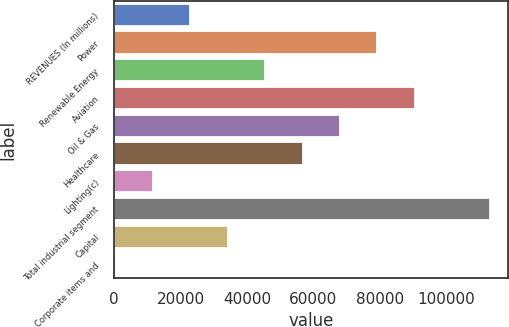Convert chart to OTSL. <chart><loc_0><loc_0><loc_500><loc_500><bar_chart><fcel>REVENUES (In millions)<fcel>Power<fcel>Renewable Energy<fcel>Aviation<fcel>Oil & Gas<fcel>Healthcare<fcel>Lighting(c)<fcel>Total industrial segment<fcel>Capital<fcel>Corporate items and<nl><fcel>22967.6<fcel>79229.1<fcel>45472.2<fcel>90481.4<fcel>67976.8<fcel>56724.5<fcel>11715.3<fcel>112986<fcel>34219.9<fcel>463<nl></chart> 